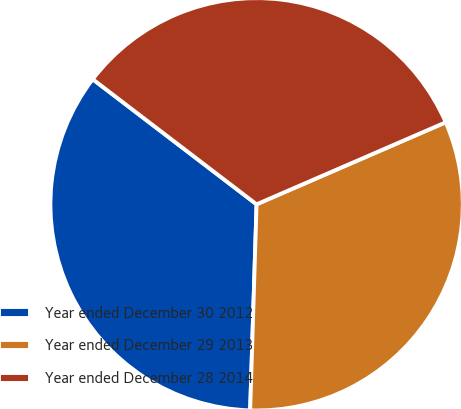Convert chart. <chart><loc_0><loc_0><loc_500><loc_500><pie_chart><fcel>Year ended December 30 2012<fcel>Year ended December 29 2013<fcel>Year ended December 28 2014<nl><fcel>34.88%<fcel>32.01%<fcel>33.11%<nl></chart> 